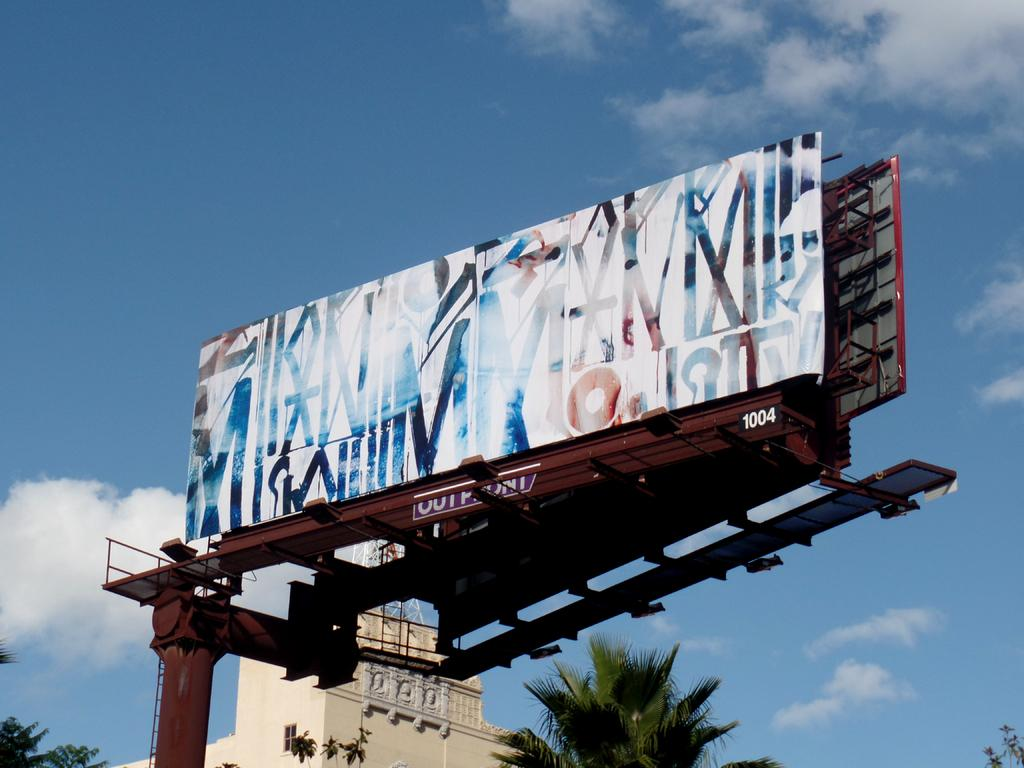<image>
Present a compact description of the photo's key features. billboard 1004 with abstract blue, red, and black letters on a white background. 